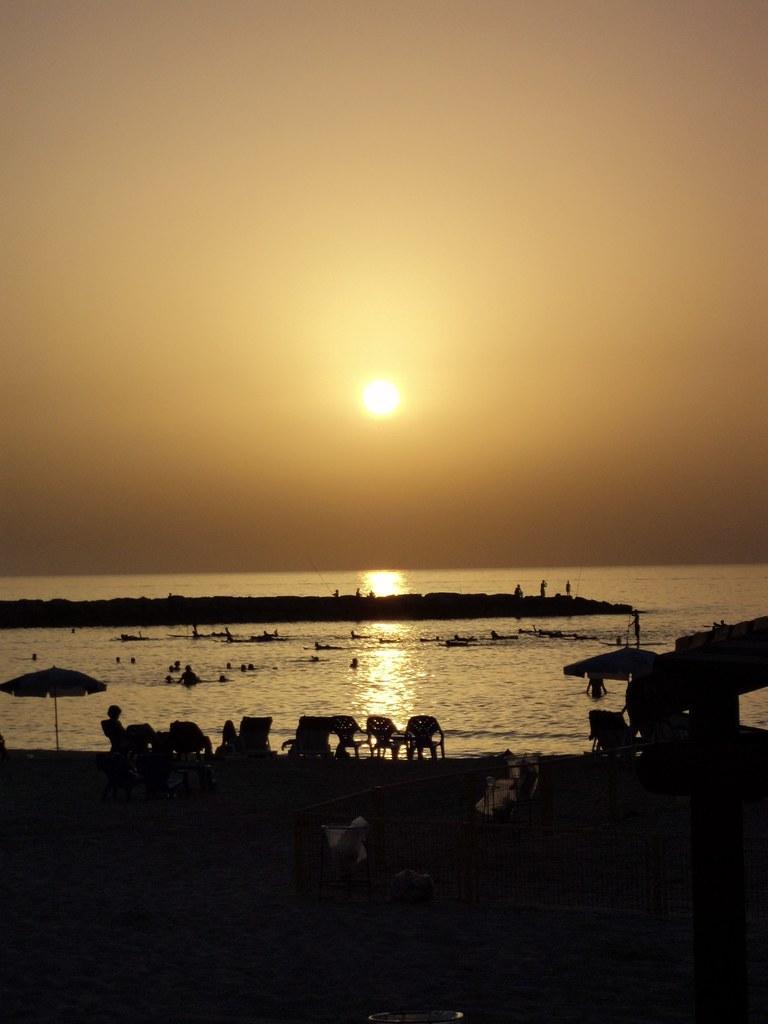Please provide a concise description of this image. The picture is taken during sunset. At the top there is sun in the sky. In the center it is water and rock. In the foreground there are chairs, umbrellas and people. 